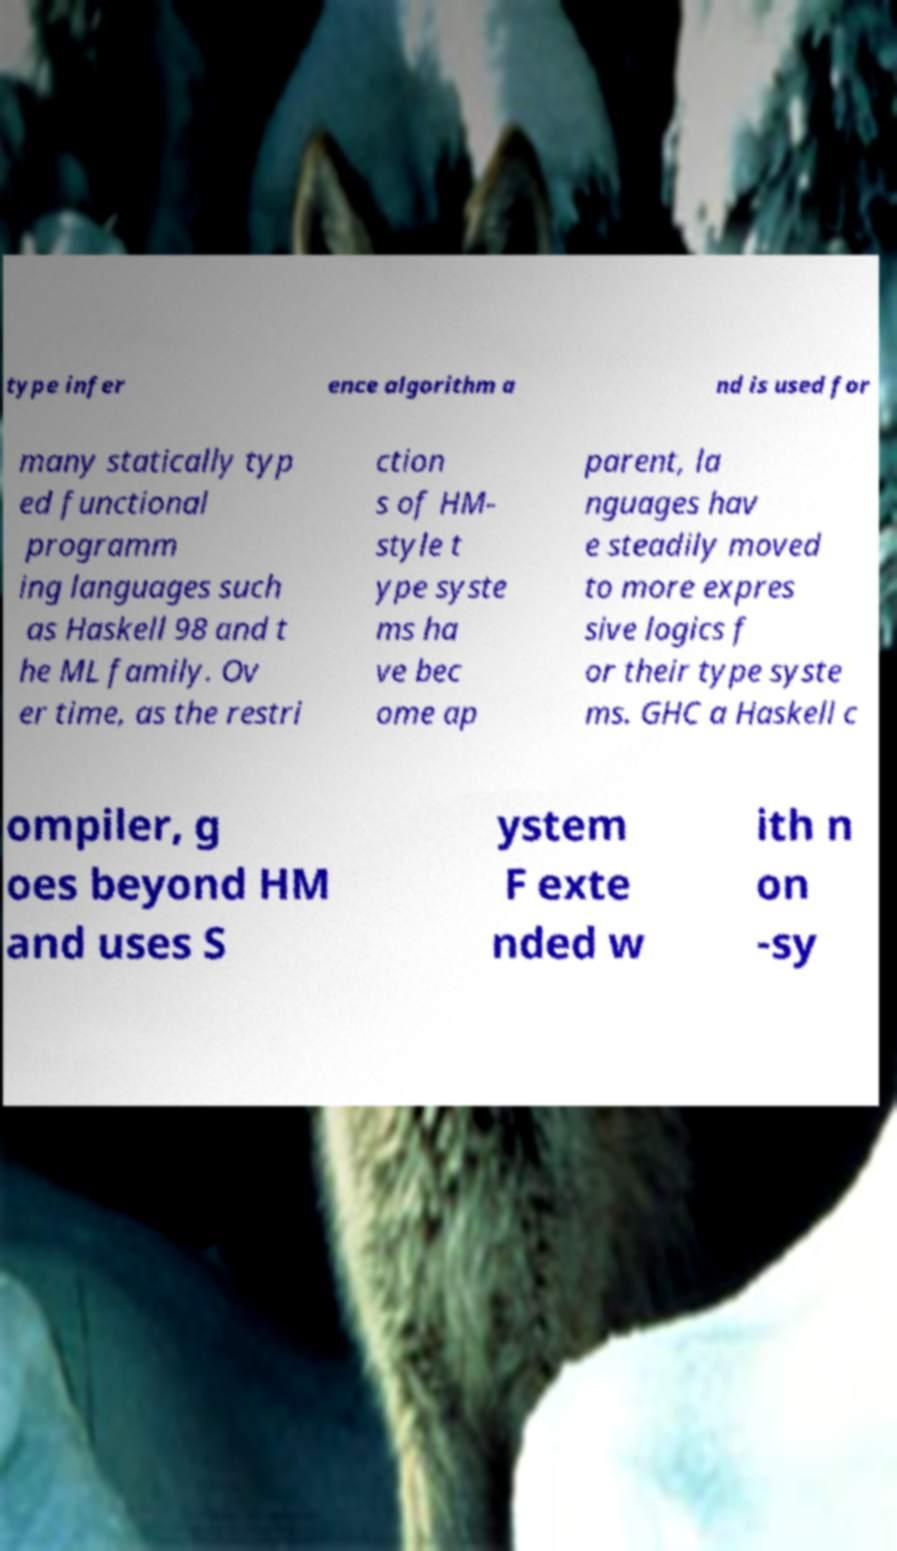Could you assist in decoding the text presented in this image and type it out clearly? type infer ence algorithm a nd is used for many statically typ ed functional programm ing languages such as Haskell 98 and t he ML family. Ov er time, as the restri ction s of HM- style t ype syste ms ha ve bec ome ap parent, la nguages hav e steadily moved to more expres sive logics f or their type syste ms. GHC a Haskell c ompiler, g oes beyond HM and uses S ystem F exte nded w ith n on -sy 